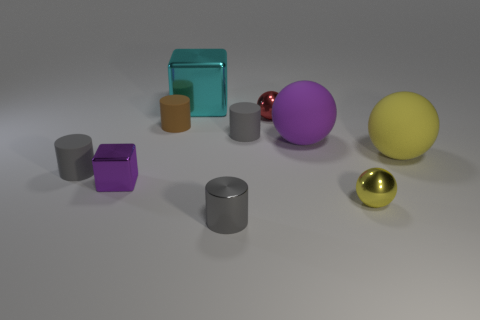How many gray cylinders must be subtracted to get 1 gray cylinders? 2 Subtract all blue cubes. How many gray cylinders are left? 3 Subtract all red cylinders. Subtract all purple balls. How many cylinders are left? 4 Subtract all balls. How many objects are left? 6 Add 2 purple shiny objects. How many purple shiny objects exist? 3 Subtract 0 gray balls. How many objects are left? 10 Subtract all green cubes. Subtract all tiny brown cylinders. How many objects are left? 9 Add 3 small brown matte cylinders. How many small brown matte cylinders are left? 4 